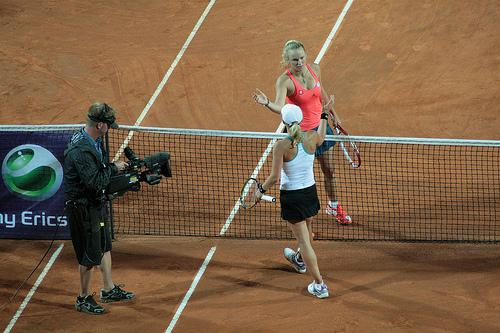Question: who playing a game?
Choices:
A. Children.
B. Two women.
C. The team.
D. Clowns.
Answer with the letter. Answer: B Question: why are they both next to the net?
Choices:
A. To congratulate each other.
B. To hit the ball.
C. To guard the next play.
D. To jump over and get to the other side.
Answer with the letter. Answer: A Question: where is this scene?
Choices:
A. A tennis court.
B. Backyard.
C. Tennis Court.
D. Park.
Answer with the letter. Answer: A Question: what are the women holding?
Choices:
A. Tennis rackets.
B. Sweat bands.
C. Tennis balls.
D. Water.
Answer with the letter. Answer: A Question: what hairstyle do the women have?
Choices:
A. Ponytail.
B. Braid.
C. Bun.
D. Short hair.
Answer with the letter. Answer: A Question: what game is this?
Choices:
A. Monopoly.
B. Baseball.
C. Tennis.
D. Football.
Answer with the letter. Answer: C 